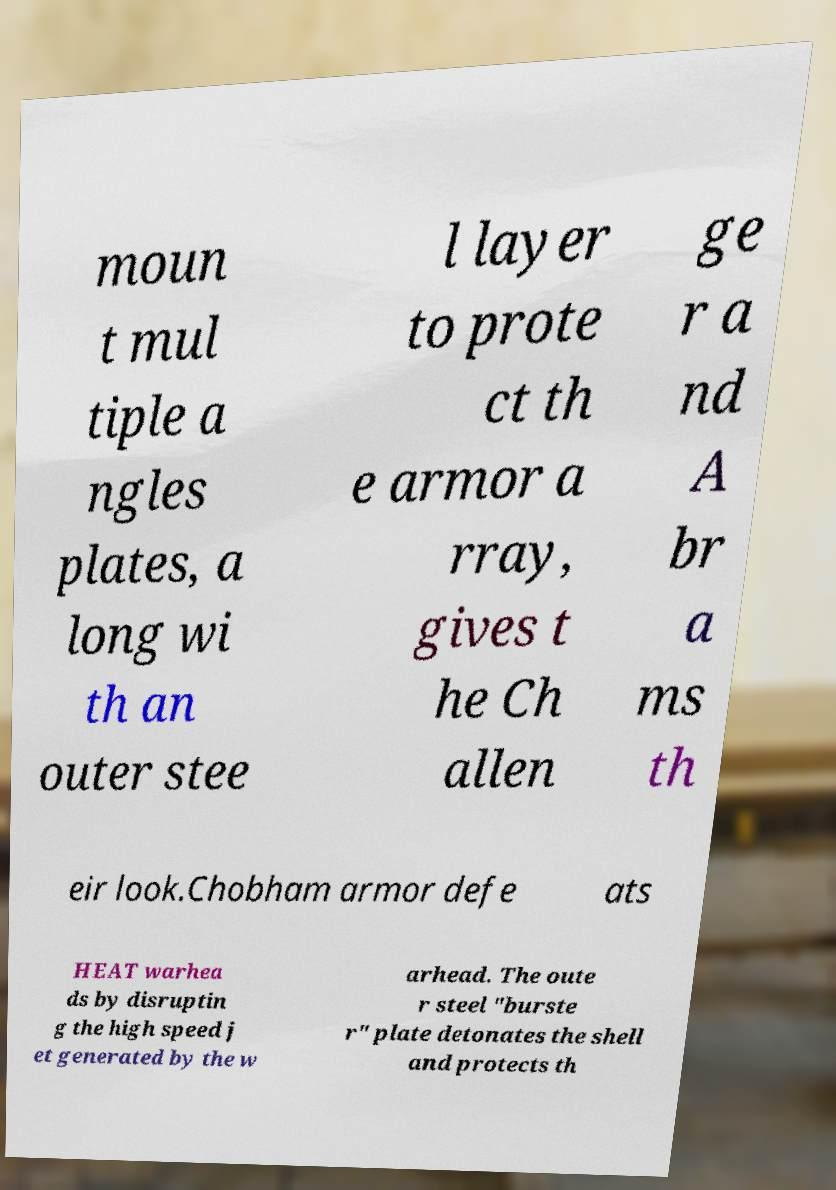Could you assist in decoding the text presented in this image and type it out clearly? moun t mul tiple a ngles plates, a long wi th an outer stee l layer to prote ct th e armor a rray, gives t he Ch allen ge r a nd A br a ms th eir look.Chobham armor defe ats HEAT warhea ds by disruptin g the high speed j et generated by the w arhead. The oute r steel "burste r" plate detonates the shell and protects th 